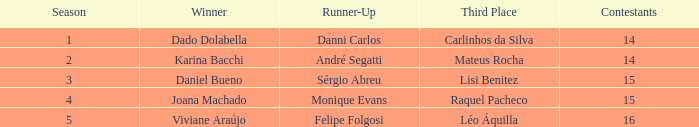Who was the victor when mateus rocha ended in 3rd position? Karina Bacchi. 